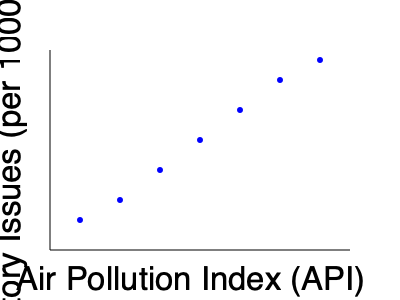As an environmental advocate, you're analyzing the relationship between air pollution and respiratory health. Based on the scatter plot, what type of correlation exists between the Air Pollution Index (API) and the number of respiratory issues per 1000 people? To determine the correlation between the Air Pollution Index (API) and respiratory issues, we need to examine the pattern of the data points in the scatter plot:

1. Observe the overall trend: As we move from left to right (increasing API), the data points generally move downward (decreasing y-axis values).

2. Consistency of the trend: The downward trend appears to be consistent across the entire range of the data.

3. Strength of the relationship: The points form a relatively tight pattern, suggesting a strong relationship.

4. Direction of the relationship: As the API increases, the number of respiratory issues decreases.

5. Linearity: The relationship appears to be approximately linear, as the points roughly follow a straight line.

Given these observations, we can conclude that there is a strong negative (or inverse) correlation between the Air Pollution Index and the number of respiratory issues per 1000 people.

This correlation is counterintuitive, as we would typically expect higher air pollution to lead to more respiratory issues. This unexpected result could be due to various factors, such as:
- Improved healthcare in more polluted areas
- People in polluted areas taking more precautions
- Other confounding variables not shown in the data

As a political strategist focused on environmental causes, this data would warrant further investigation to understand the underlying factors and potential policy implications.
Answer: Strong negative correlation 